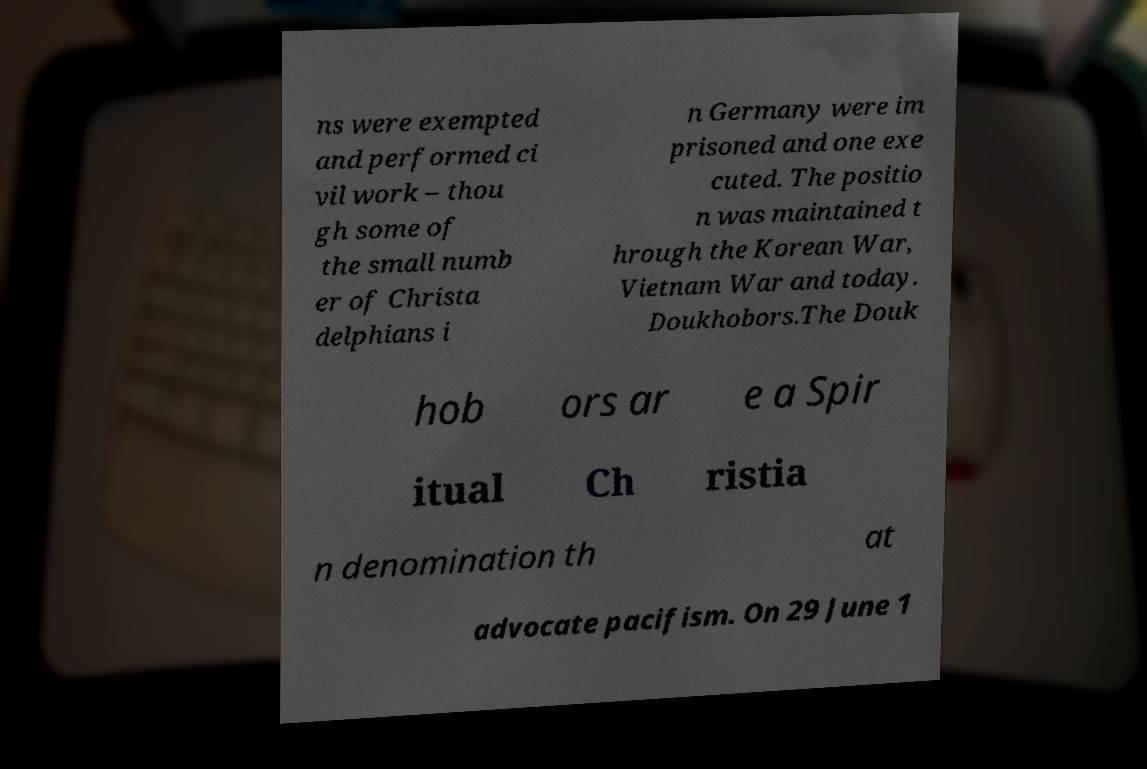Can you read and provide the text displayed in the image?This photo seems to have some interesting text. Can you extract and type it out for me? ns were exempted and performed ci vil work – thou gh some of the small numb er of Christa delphians i n Germany were im prisoned and one exe cuted. The positio n was maintained t hrough the Korean War, Vietnam War and today. Doukhobors.The Douk hob ors ar e a Spir itual Ch ristia n denomination th at advocate pacifism. On 29 June 1 